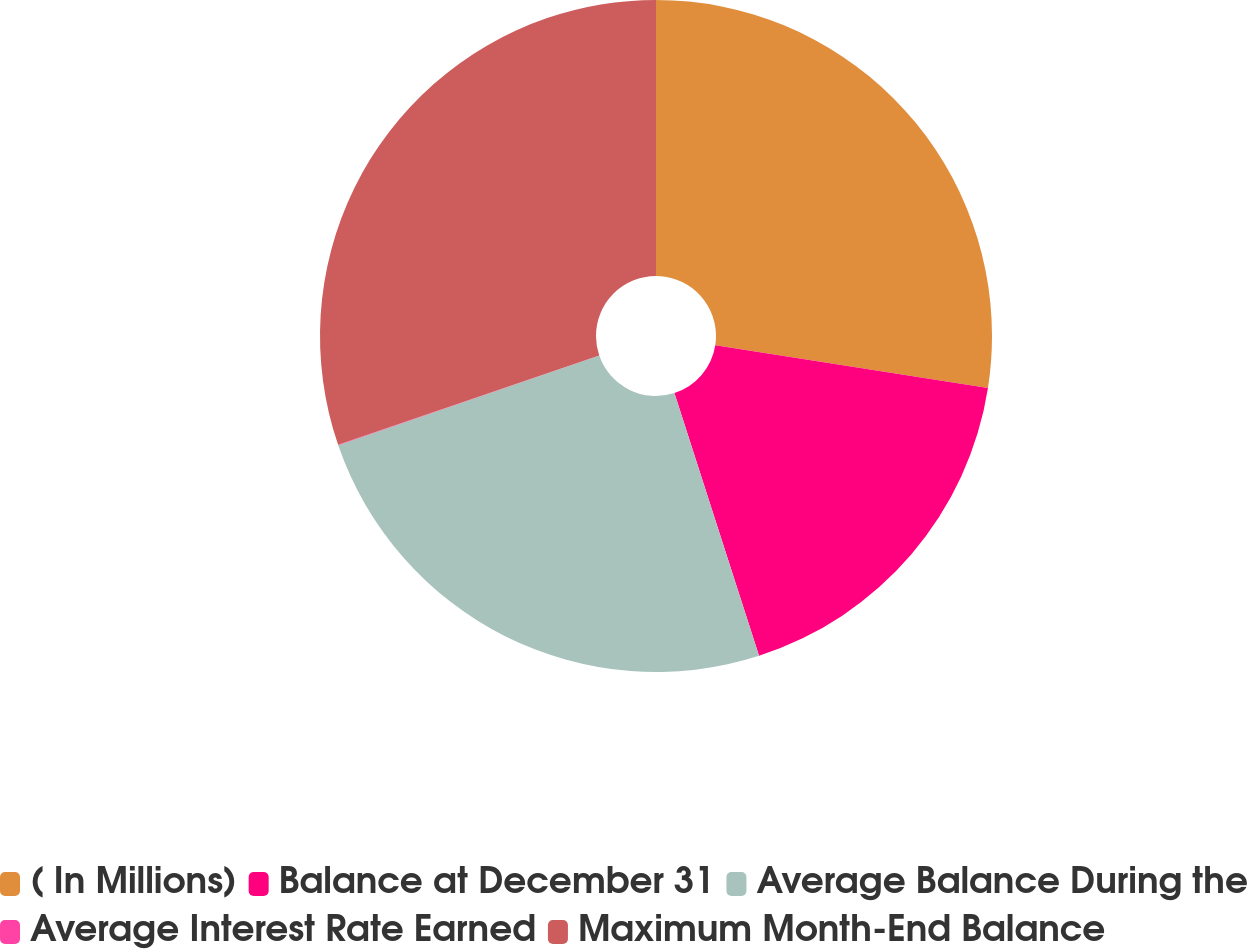Convert chart to OTSL. <chart><loc_0><loc_0><loc_500><loc_500><pie_chart><fcel>( In Millions)<fcel>Balance at December 31<fcel>Average Balance During the<fcel>Average Interest Rate Earned<fcel>Maximum Month-End Balance<nl><fcel>27.47%<fcel>17.57%<fcel>24.69%<fcel>0.02%<fcel>30.25%<nl></chart> 